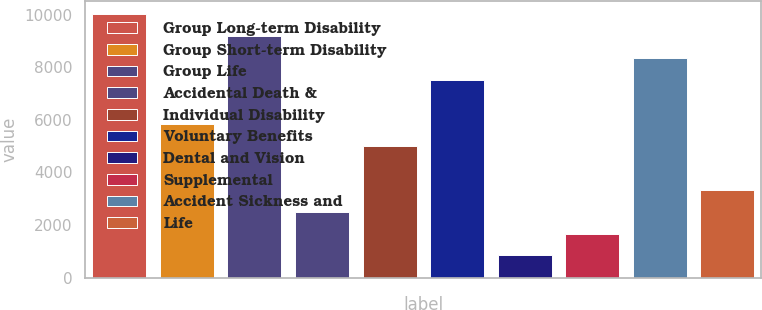Convert chart to OTSL. <chart><loc_0><loc_0><loc_500><loc_500><bar_chart><fcel>Group Long-term Disability<fcel>Group Short-term Disability<fcel>Group Life<fcel>Accidental Death &<fcel>Individual Disability<fcel>Voluntary Benefits<fcel>Dental and Vision<fcel>Supplemental<fcel>Accident Sickness and<fcel>Life<nl><fcel>10028.3<fcel>5851.77<fcel>9193.01<fcel>2510.53<fcel>5016.46<fcel>7522.39<fcel>839.91<fcel>1675.22<fcel>8357.7<fcel>3345.84<nl></chart> 